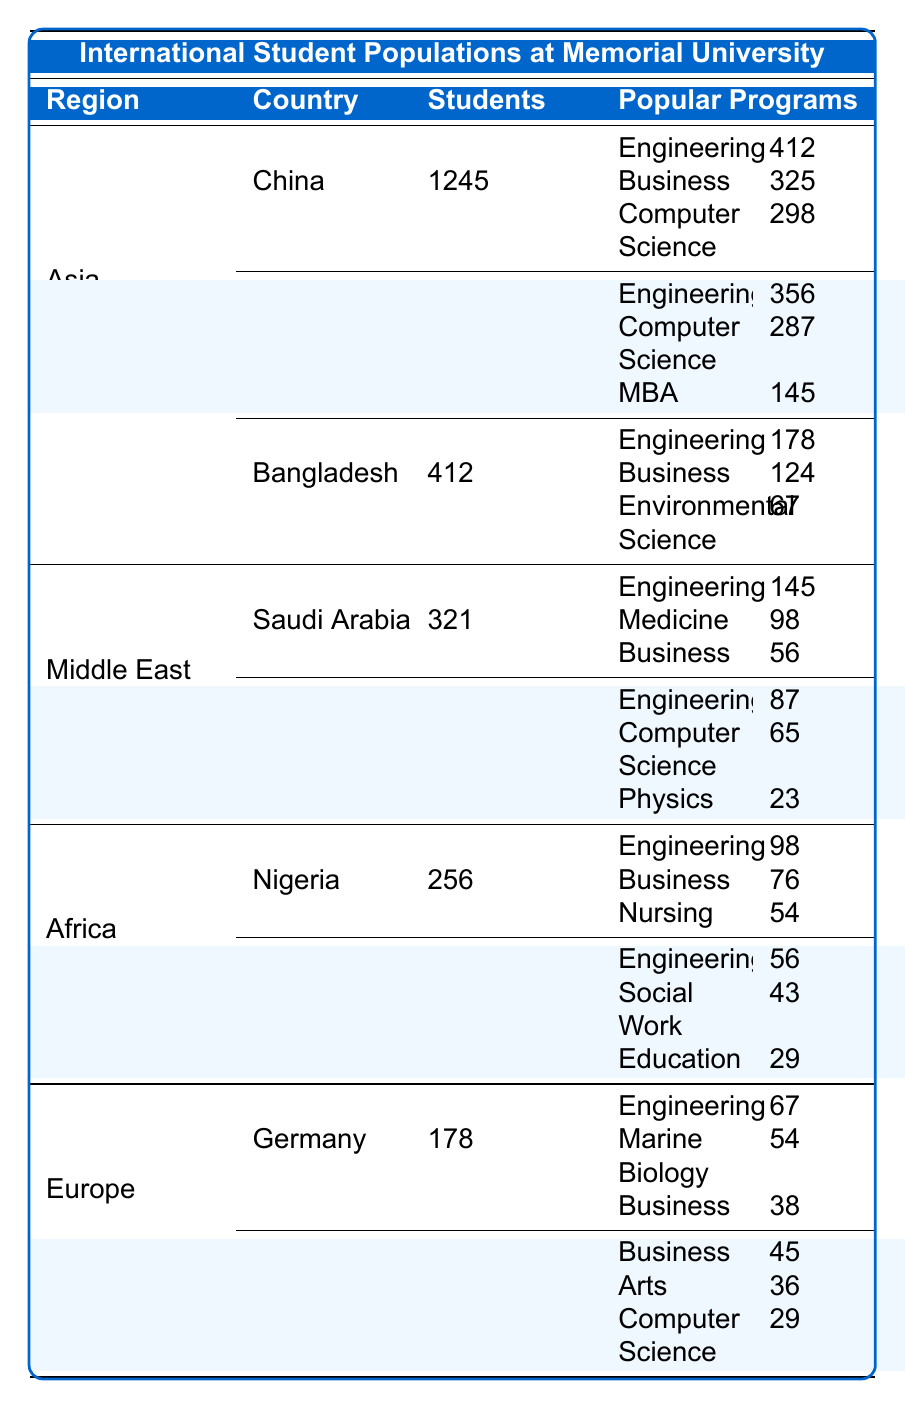What is the total number of international students from China? The table lists China as having 1245 students.
Answer: 1245 What are the three most popular programs among Indian students? The table indicates that in India, the most popular programs are Engineering (356), Computer Science (287), and MBA (145).
Answer: Engineering, Computer Science, MBA Which country has the least number of international students at Memorial University? The table shows Ghana with 143 students as the country with the least number of international students.
Answer: Ghana How many students from the Middle East study Engineering? Summing the students from Saudi Arabia (145) and Iran (87) gives a total of 232 students studying Engineering in the Middle East.
Answer: 232 Is the enrollment in Computer Science for students from India higher than that for Iran? The enrollment for India in Computer Science is 287 while for Iran it is 65, indicating that India has a higher enrollment.
Answer: Yes What is the total number of students from Africa at Memorial University? Africa has Nigeria (256) and Ghana (143), summing these gives a total of 399 students from Africa.
Answer: 399 How many students from Germany are enrolled in Marine Biology? The table specifies that 54 students from Germany are enrolled in Marine Biology.
Answer: 54 What is the difference in the number of students between China and India? The number of students from China is 1245 and from India is 876; the difference is 1245 - 876 = 369.
Answer: 369 If you combine the total number of students from Asia and Africa, how many do you get? The total from Asia is 1245 (China) + 876 (India) + 412 (Bangladesh) = 2533. From Africa, the total is 256 (Nigeria) + 143 (Ghana) = 399. Combined total is 2533 + 399 = 2932.
Answer: 2932 Are there more students from Saudi Arabia or Nigeria at Memorial University? Saudi Arabia has 321 students while Nigeria has 256 students; thus, Saudi Arabia has more students.
Answer: Saudi Arabia 